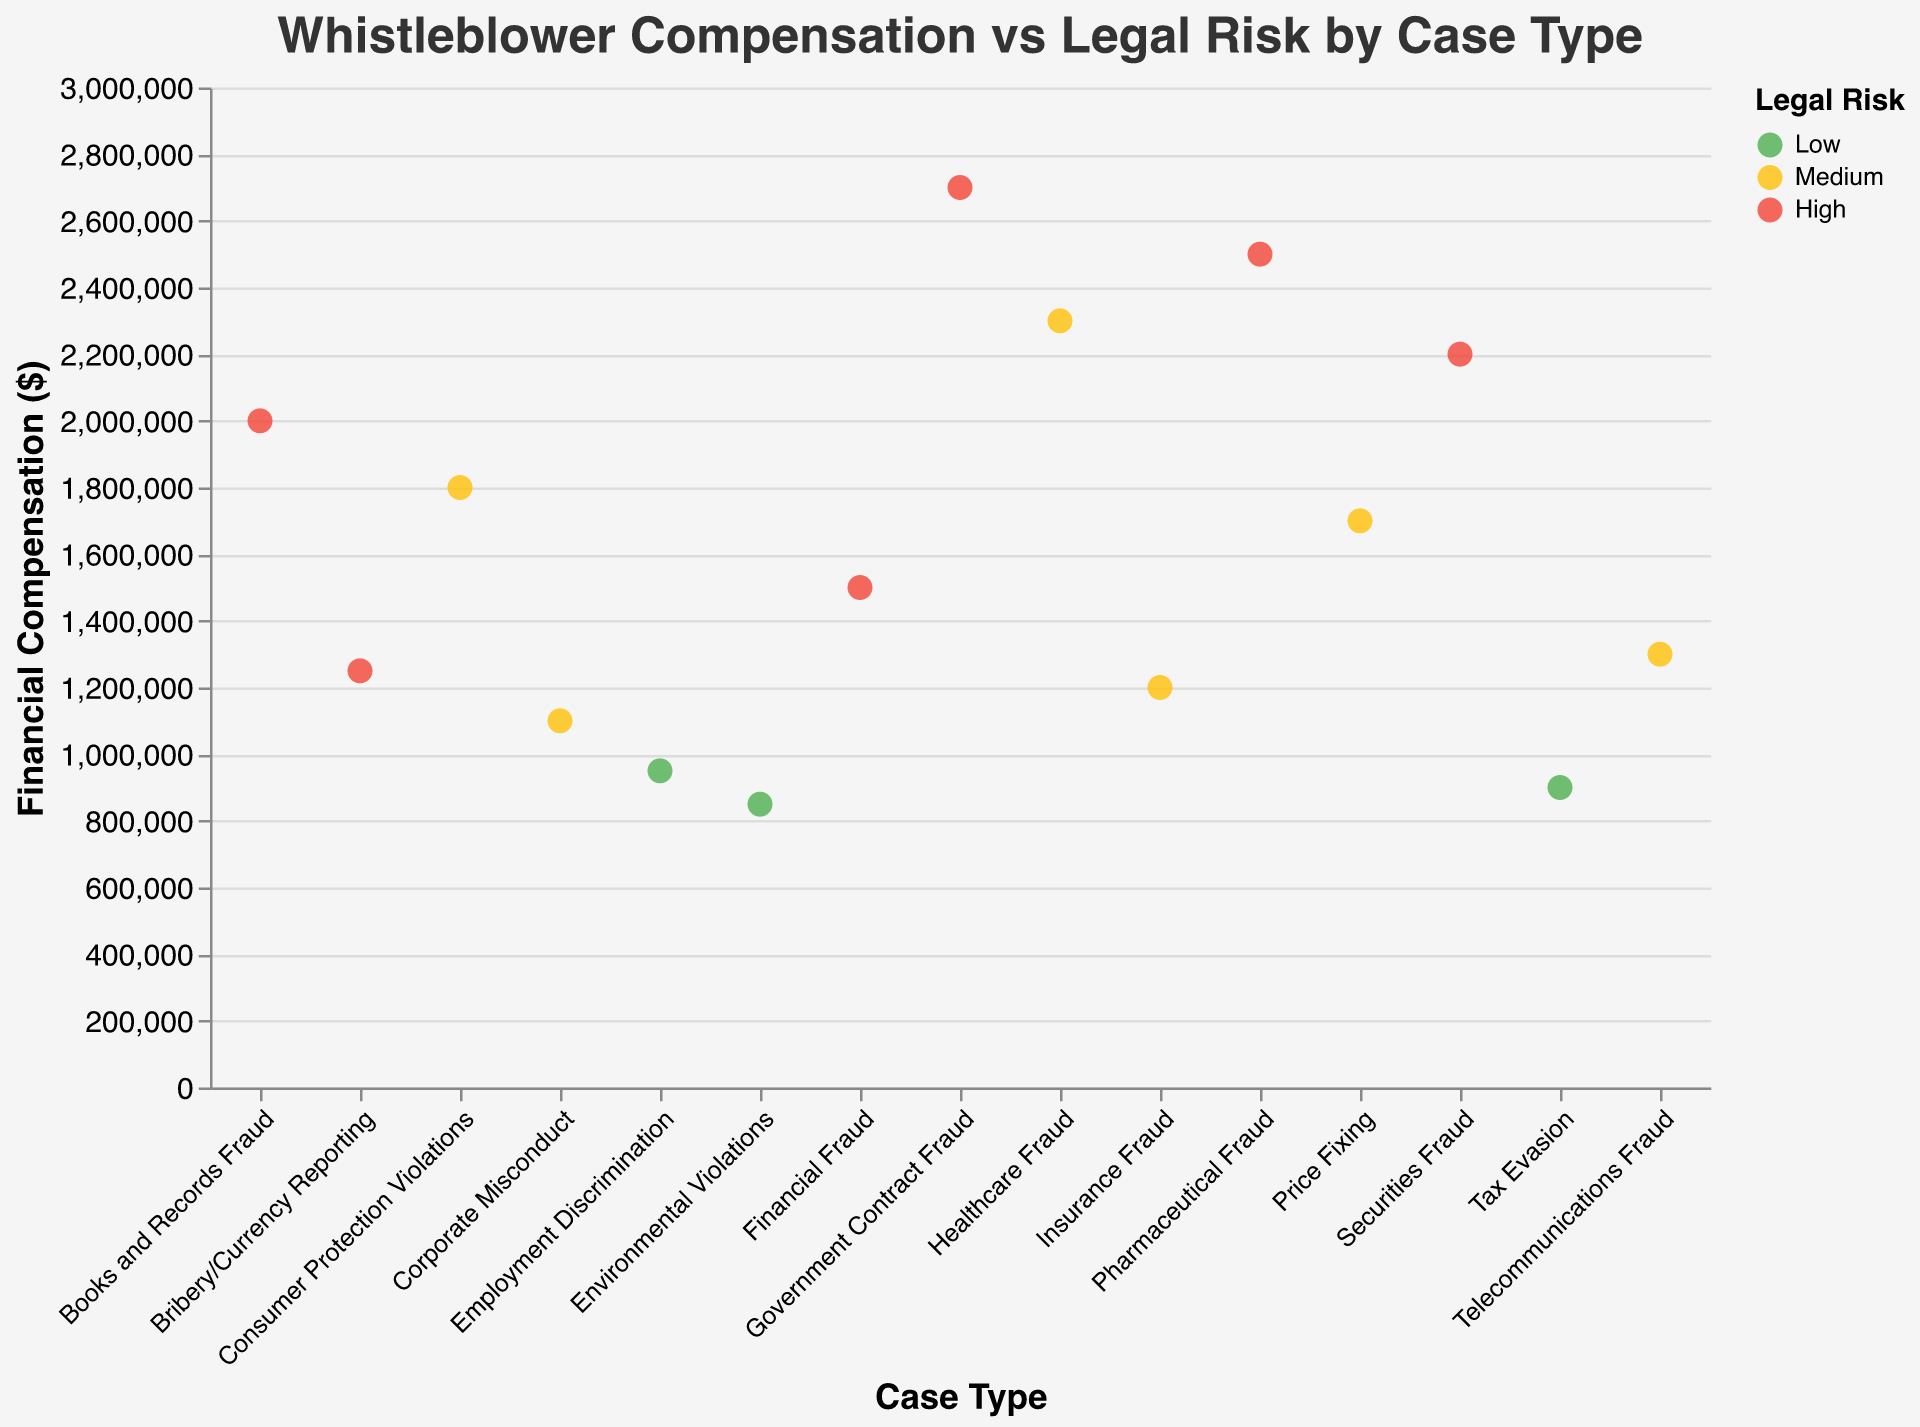What is the title of the plot? The title of the plot is displayed at the top of the figure. By reading the title, we can understand the main focus of the plot.
Answer: "Whistleblower Compensation vs Legal Risk by Case Type" How many case types have a high legal risk? The color legend shows that 'High' legal risk is represented by the color red. By counting the red points on the scatter plot, we can determine the number of case types with high legal risk.
Answer: 6 Which case type has the highest financial compensation? The y-axis represents financial compensation. By identifying the point that reaches the highest value on the y-axis, we can find the case type with the highest compensation. This case type is associated with Maria Garcia under "Government Contract Fraud."
Answer: Government Contract Fraud What is the financial compensation for the "Books and Records Fraud" case type? To find this, locate the point corresponding to "Books and Records Fraud" on the x-axis and check its position on the y-axis. The tooltip or color legend can also be used to verify the value.
Answer: $2,000,000 Compare the legal risk between “Healthcare Fraud” and “Financial Fraud.” Which one has a higher risk? Locate the points for "Healthcare Fraud" and "Financial Fraud" on the x-axis and observe their colors. "Financial Fraud" is red (High risk) and "Healthcare Fraud" is yellow (Medium risk), indicating that "Financial Fraud" has a higher legal risk.
Answer: Financial Fraud What is the average financial compensation for case types with medium legal risk? Identify the points with medium legal risk (yellow color). Then, sum the financial compensations for these points and divide by the number of points to calculate the average.
Answer: $1,575,000 Which case type associated with “High” legal risk has the lowest financial compensation? Filter the points with a red color indicating high legal risk and identify the one with the lowest y-value among them.
Answer: Financial Fraud What is the difference in financial compensation between "Pharmaceutical Fraud" and "Environmental Violations"? Find the financial compensations for "Pharmaceutical Fraud" and "Environmental Violations" on the y-axis. Subtract the compensation of "Environmental Violations" from "Pharmaceutical Fraud." ($2,500,000 - $850,000).
Answer: $1,650,000 How does the legal risk distribution look among the different case types? By examining the colors of the points, we can infer that the legal risk distribution varies with more case types in "High" and "Medium" categories compared to "Low." Each color represents a different risk level.
Answer: Varied distribution, more high and medium risks Which case types fall under the "Low" legal risk category and what are their financial compensations? Identify the green-colored points on the plot representing low legal risk and read their financial compensations on the y-axis. They are "Tax Evasion," "Environmental Violations," and "Employment Discrimination."
Answer: Tax Evasion: $900,000, Environmental Violations: $850,000, Employment Discrimination: $950,000 